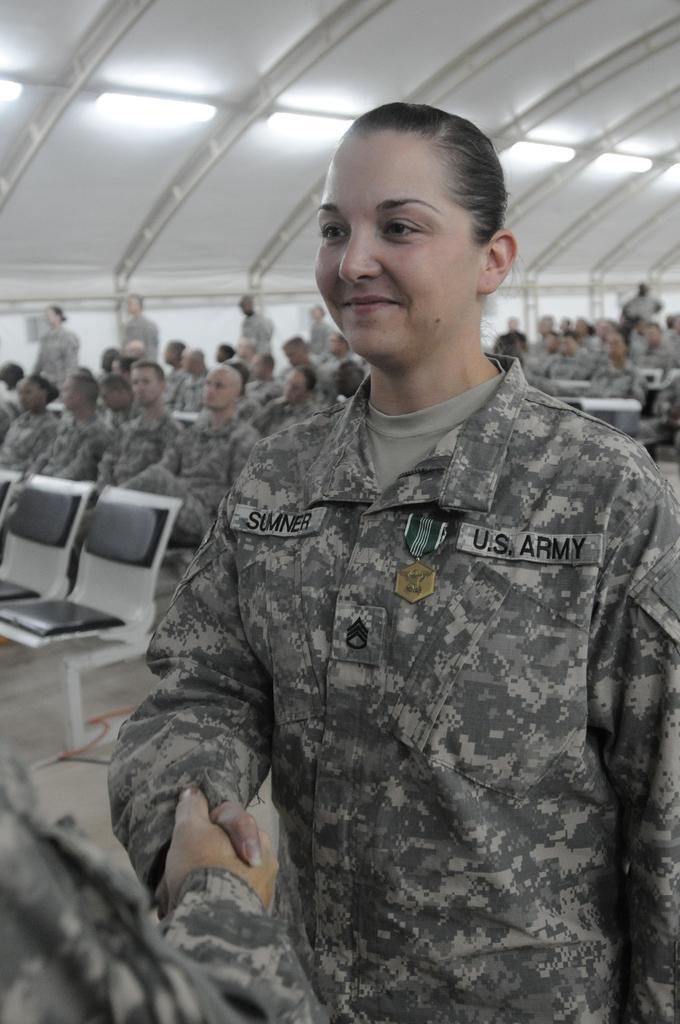How would you summarize this image in a sentence or two? In this image I can see a person wearing military uniform is standing. In the background I can see few persons are sitting on chairs and few of them are standing. I can see the wall, the ceiling and few lights to the ceiling. 